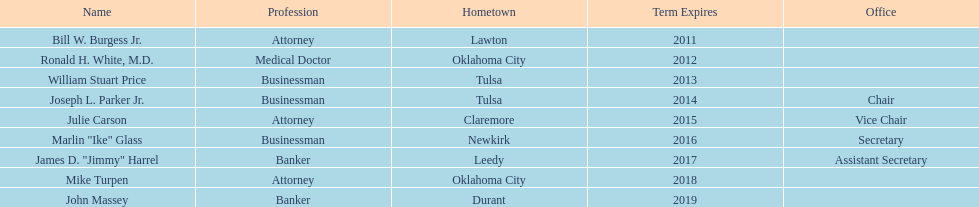Could you parse the entire table as a dict? {'header': ['Name', 'Profession', 'Hometown', 'Term Expires', 'Office'], 'rows': [['Bill W. Burgess Jr.', 'Attorney', 'Lawton', '2011', ''], ['Ronald H. White, M.D.', 'Medical Doctor', 'Oklahoma City', '2012', ''], ['William Stuart Price', 'Businessman', 'Tulsa', '2013', ''], ['Joseph L. Parker Jr.', 'Businessman', 'Tulsa', '2014', 'Chair'], ['Julie Carson', 'Attorney', 'Claremore', '2015', 'Vice Chair'], ['Marlin "Ike" Glass', 'Businessman', 'Newkirk', '2016', 'Secretary'], ['James D. "Jimmy" Harrel', 'Banker', 'Leedy', '2017', 'Assistant Secretary'], ['Mike Turpen', 'Attorney', 'Oklahoma City', '2018', ''], ['John Massey', 'Banker', 'Durant', '2019', '']]} Which state regent is from the same hometown as ronald h. white, m.d.? Mike Turpen. 